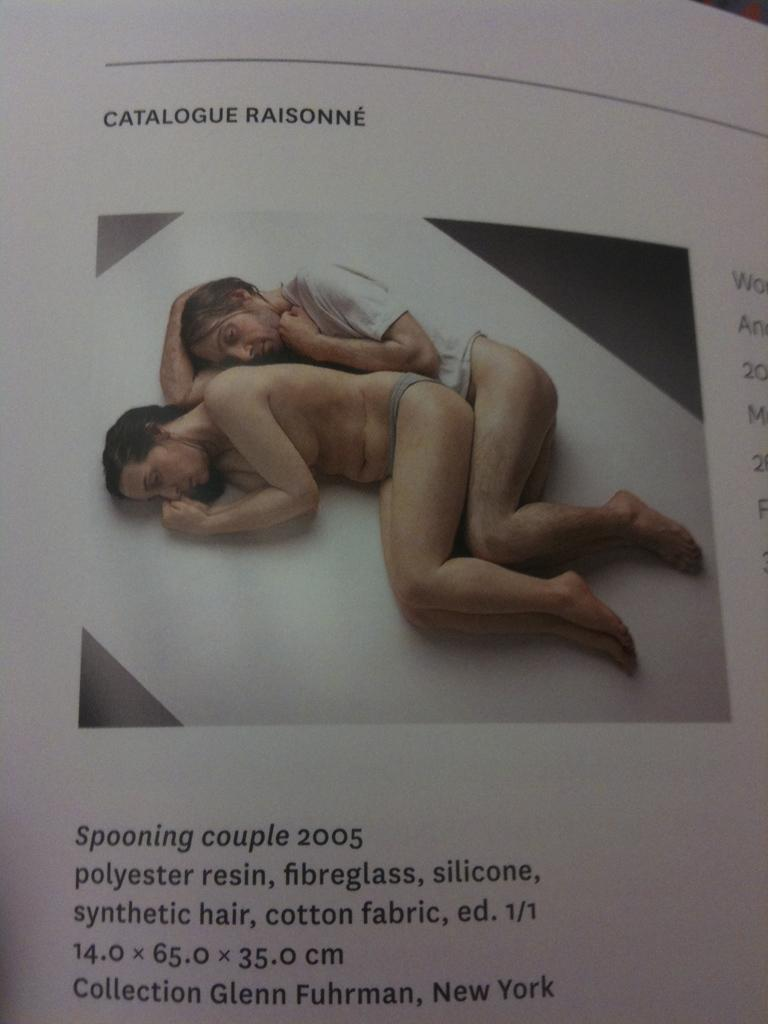What is present on the paper in the image? There is a picture on the paper, and words are written on the paper with black color. Can you describe the picture on the paper? The picture contains two persons who are sleeping. What color is the surface the two persons are sleeping on? The surface they are sleeping on is white colored. How many quinces are visible in the image? There are no quinces present in the image. What type of ball is being used by the two persons in the image? There is no ball present in the image; the two persons are sleeping. 